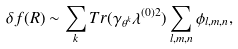<formula> <loc_0><loc_0><loc_500><loc_500>\delta f ( R ) \sim \sum _ { k } T r ( \gamma _ { \theta ^ { k } } \lambda ^ { ( 0 ) 2 } ) \sum _ { l , m , n } \phi _ { l , m , n } ,</formula> 